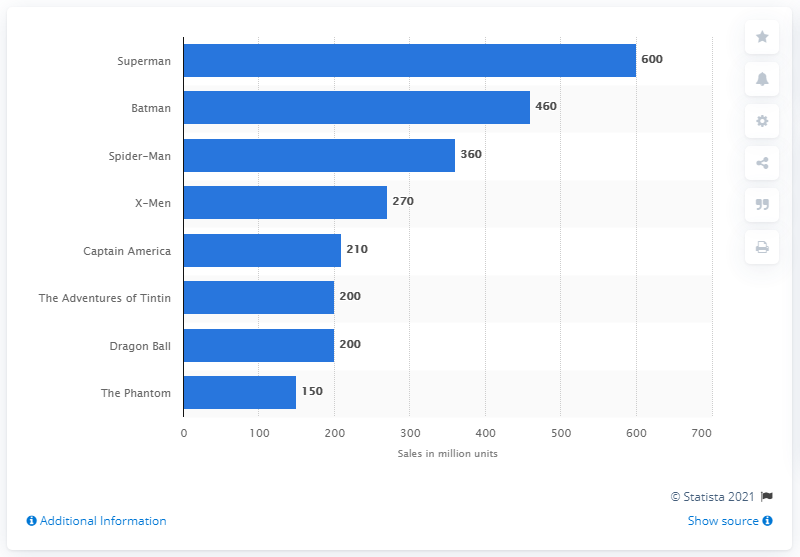Outline some significant characteristics in this image. Superman has sold a total of 600 copies worldwide. Action Comics' thousandth issue sold 600 copies. The best-selling comic book series of all time is Superman. 